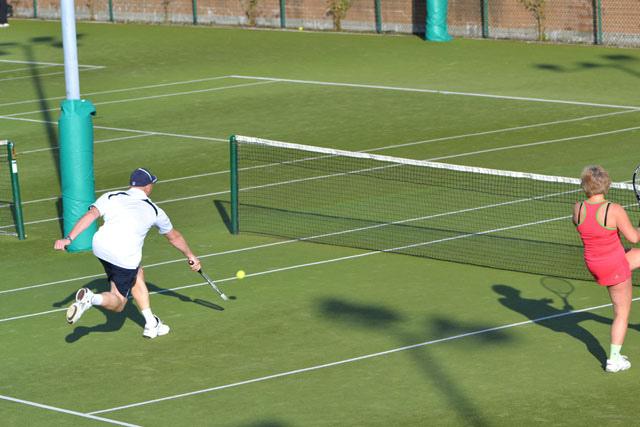Is the woman trying to rest?
Keep it brief. No. What sport is shown?
Quick response, please. Tennis. What color is the court?
Concise answer only. Green. 